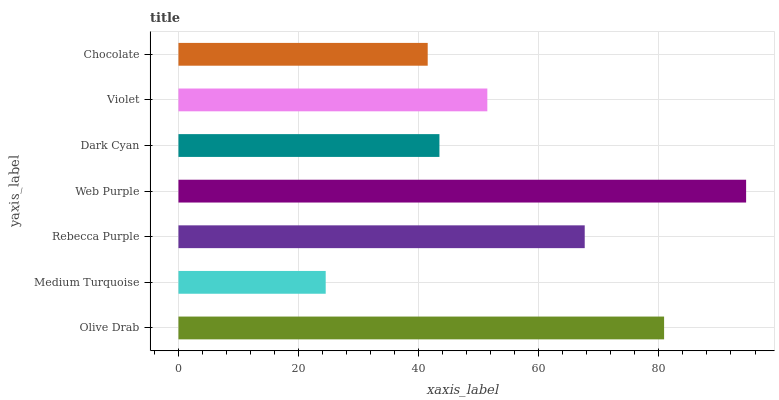Is Medium Turquoise the minimum?
Answer yes or no. Yes. Is Web Purple the maximum?
Answer yes or no. Yes. Is Rebecca Purple the minimum?
Answer yes or no. No. Is Rebecca Purple the maximum?
Answer yes or no. No. Is Rebecca Purple greater than Medium Turquoise?
Answer yes or no. Yes. Is Medium Turquoise less than Rebecca Purple?
Answer yes or no. Yes. Is Medium Turquoise greater than Rebecca Purple?
Answer yes or no. No. Is Rebecca Purple less than Medium Turquoise?
Answer yes or no. No. Is Violet the high median?
Answer yes or no. Yes. Is Violet the low median?
Answer yes or no. Yes. Is Olive Drab the high median?
Answer yes or no. No. Is Medium Turquoise the low median?
Answer yes or no. No. 